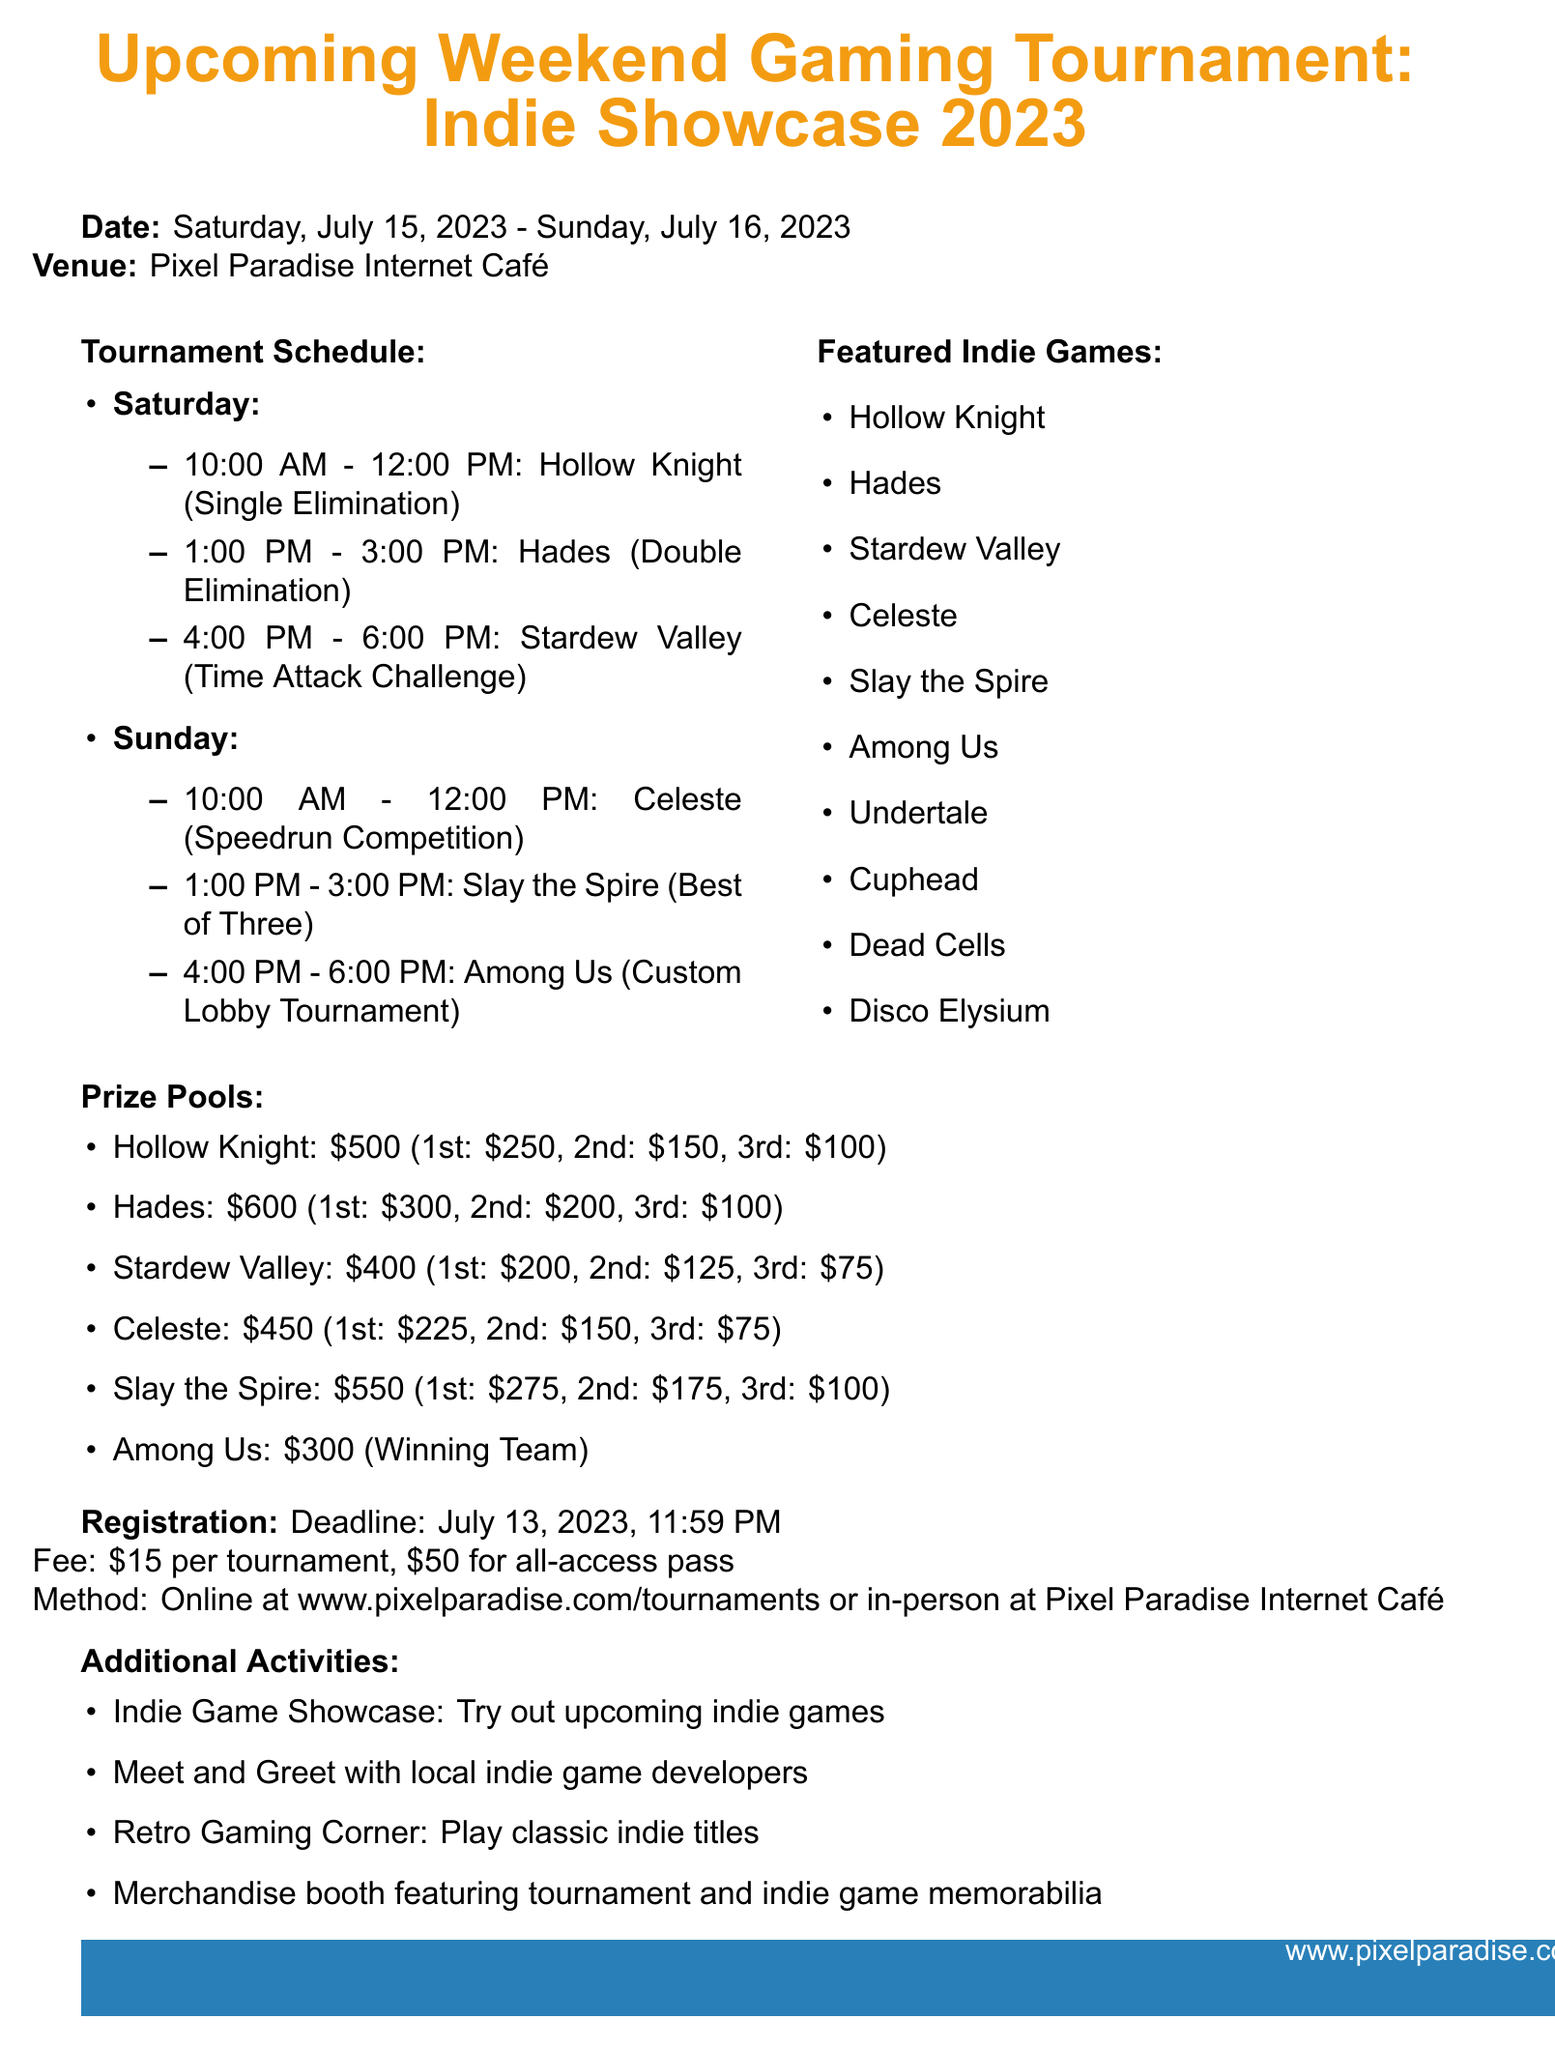What are the dates of the tournament? The dates of the tournament are clearly specified in the document.
Answer: Saturday, July 15, 2023 - Sunday, July 16, 2023 What is the registration deadline? The registration deadline is mentioned in the registration section.
Answer: July 13, 2023, 11:59 PM How many events are scheduled for Saturday? The total number of Saturday events can be counted from the tournament schedule section.
Answer: 3 What prize is awarded for 1st place in Hades? The prize for 1st place in Hades is explicitly stated in the prize pool details.
Answer: $300 Which indie game is featured first in the schedule? The first indie game listed in the Saturday schedule indicates the answer.
Answer: Hollow Knight What is the prize pool total for Among Us? The total prize pool for Among Us is listed in the prize details.
Answer: $300 What format is used for the Stardew Valley tournament? The format for the Stardew Valley tournament is provided in the Saturday events.
Answer: Time Attack Challenge How much is the all-access pass for the tournament? The cost of the all-access pass is specified in the registration information.
Answer: $50 Which company is listed as a sponsor? The sponsorship section includes several companies that support the event.
Answer: Razer 